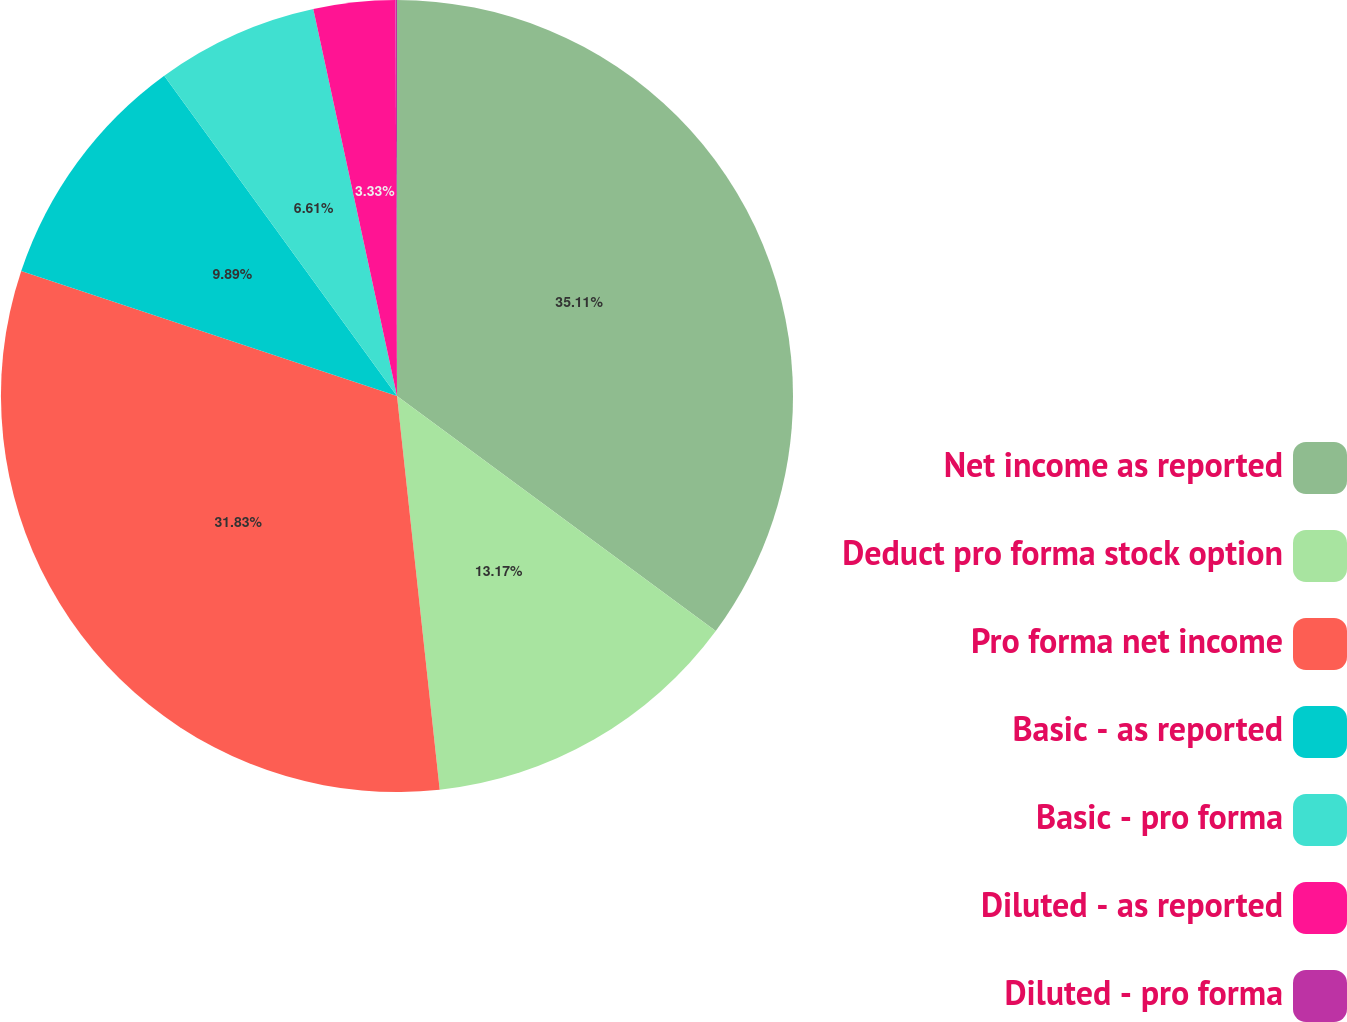Convert chart to OTSL. <chart><loc_0><loc_0><loc_500><loc_500><pie_chart><fcel>Net income as reported<fcel>Deduct pro forma stock option<fcel>Pro forma net income<fcel>Basic - as reported<fcel>Basic - pro forma<fcel>Diluted - as reported<fcel>Diluted - pro forma<nl><fcel>35.11%<fcel>13.17%<fcel>31.83%<fcel>9.89%<fcel>6.61%<fcel>3.33%<fcel>0.06%<nl></chart> 